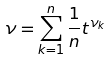Convert formula to latex. <formula><loc_0><loc_0><loc_500><loc_500>\nu = \sum _ { k = 1 } ^ { n } \frac { 1 } { n } t ^ { \nu _ { k } }</formula> 